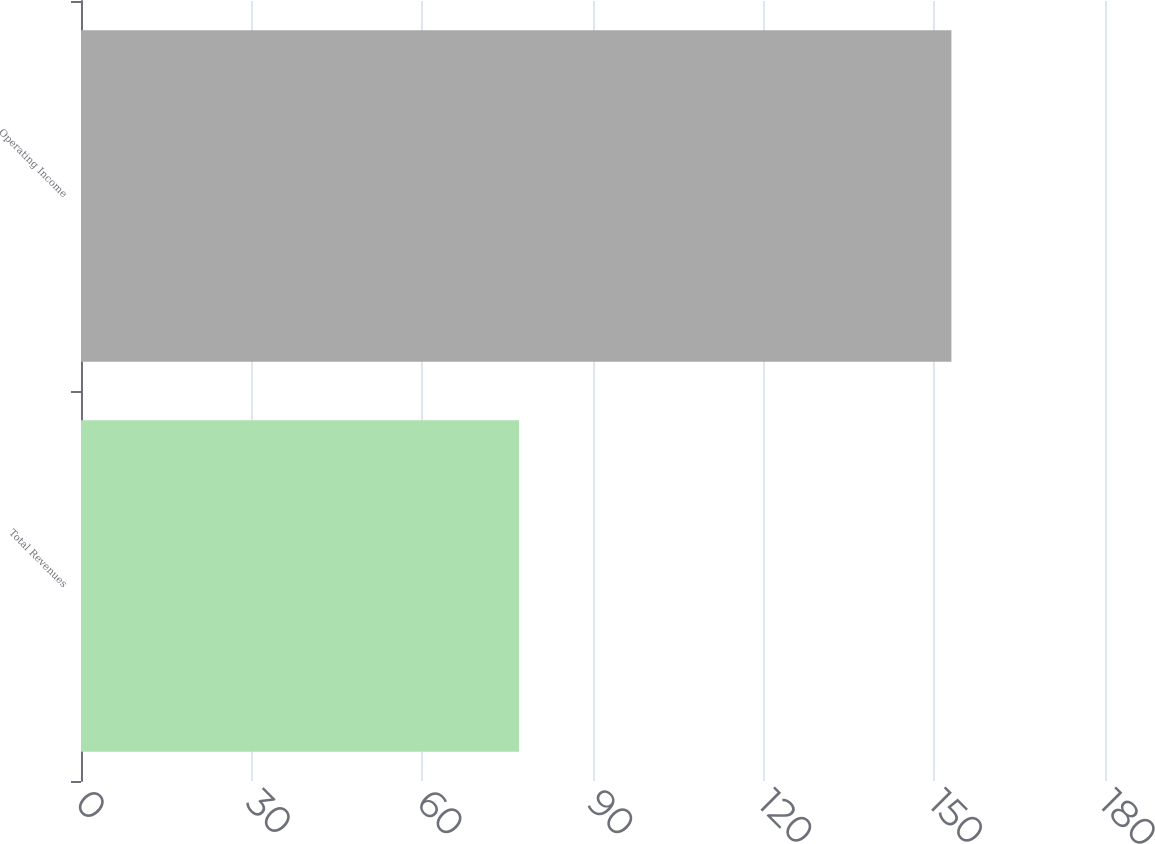Convert chart to OTSL. <chart><loc_0><loc_0><loc_500><loc_500><bar_chart><fcel>Total Revenues<fcel>Operating Income<nl><fcel>77<fcel>153<nl></chart> 